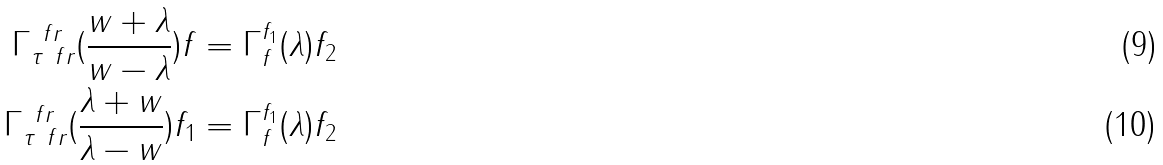Convert formula to latex. <formula><loc_0><loc_0><loc_500><loc_500>\Gamma _ { \tau \ f r } ^ { \ f r } ( \frac { w + \lambda } { w - \lambda } ) f & = \Gamma _ { f } ^ { f _ { 1 } } ( \lambda ) f _ { 2 } \\ \Gamma _ { \tau \ f r } ^ { \ f r } ( \frac { \lambda + w } { \lambda - w } ) f _ { 1 } & = \Gamma _ { f } ^ { f _ { 1 } } ( \lambda ) f _ { 2 }</formula> 